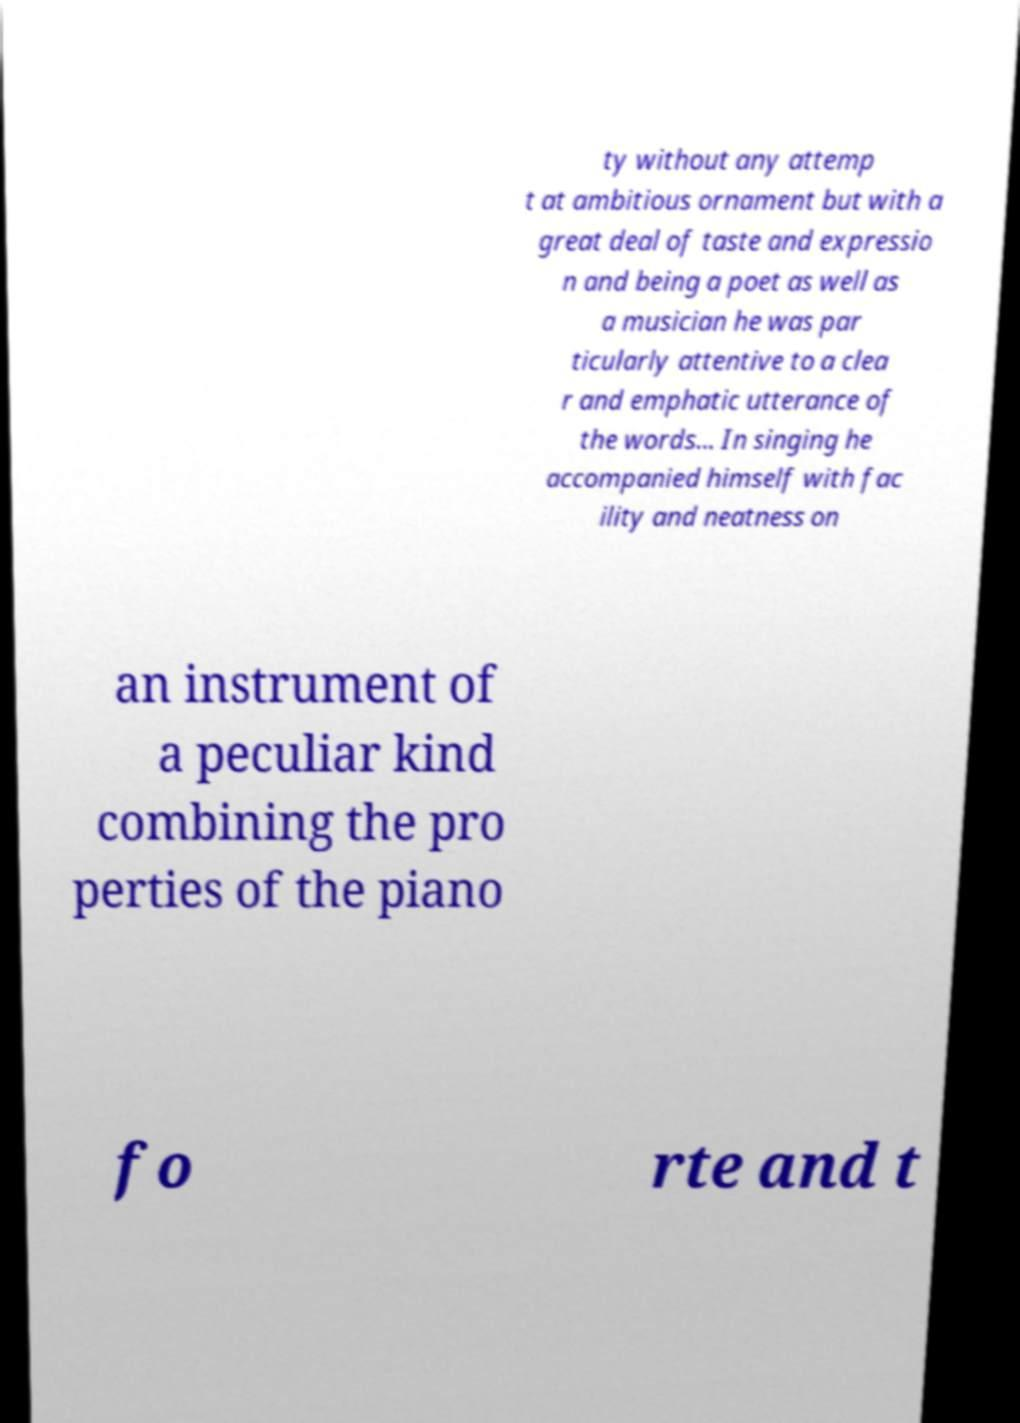Please read and relay the text visible in this image. What does it say? ty without any attemp t at ambitious ornament but with a great deal of taste and expressio n and being a poet as well as a musician he was par ticularly attentive to a clea r and emphatic utterance of the words... In singing he accompanied himself with fac ility and neatness on an instrument of a peculiar kind combining the pro perties of the piano fo rte and t 